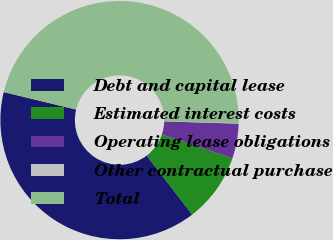<chart> <loc_0><loc_0><loc_500><loc_500><pie_chart><fcel>Debt and capital lease<fcel>Estimated interest costs<fcel>Operating lease obligations<fcel>Other contractual purchase<fcel>Total<nl><fcel>39.22%<fcel>9.38%<fcel>4.72%<fcel>0.07%<fcel>46.62%<nl></chart> 